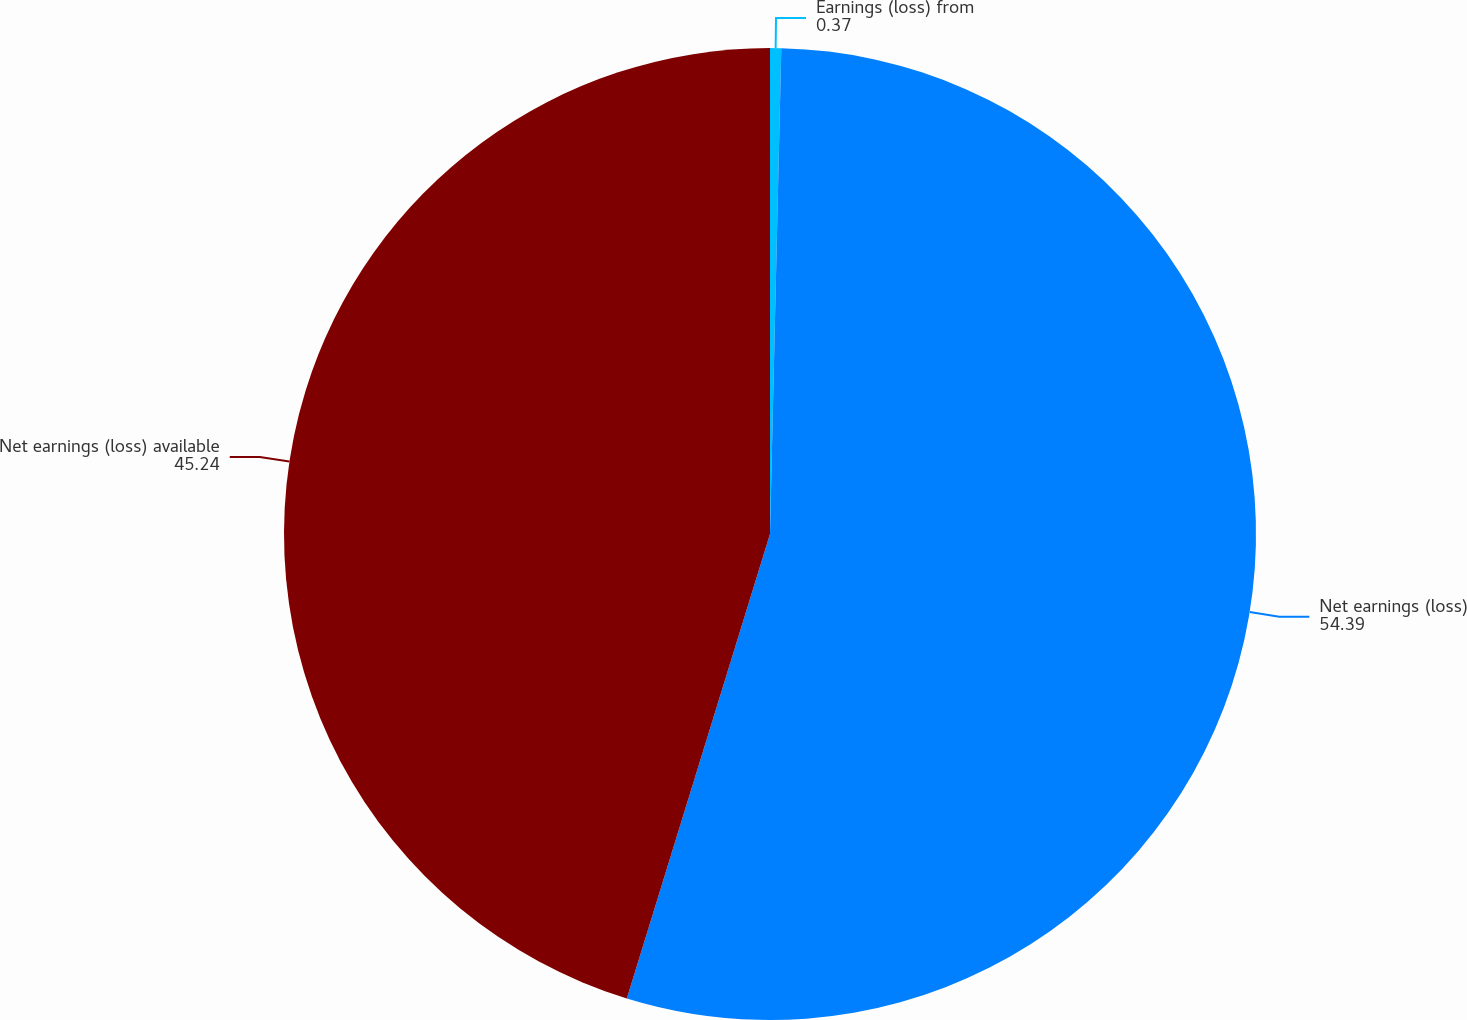Convert chart to OTSL. <chart><loc_0><loc_0><loc_500><loc_500><pie_chart><fcel>Earnings (loss) from<fcel>Net earnings (loss)<fcel>Net earnings (loss) available<nl><fcel>0.37%<fcel>54.39%<fcel>45.24%<nl></chart> 